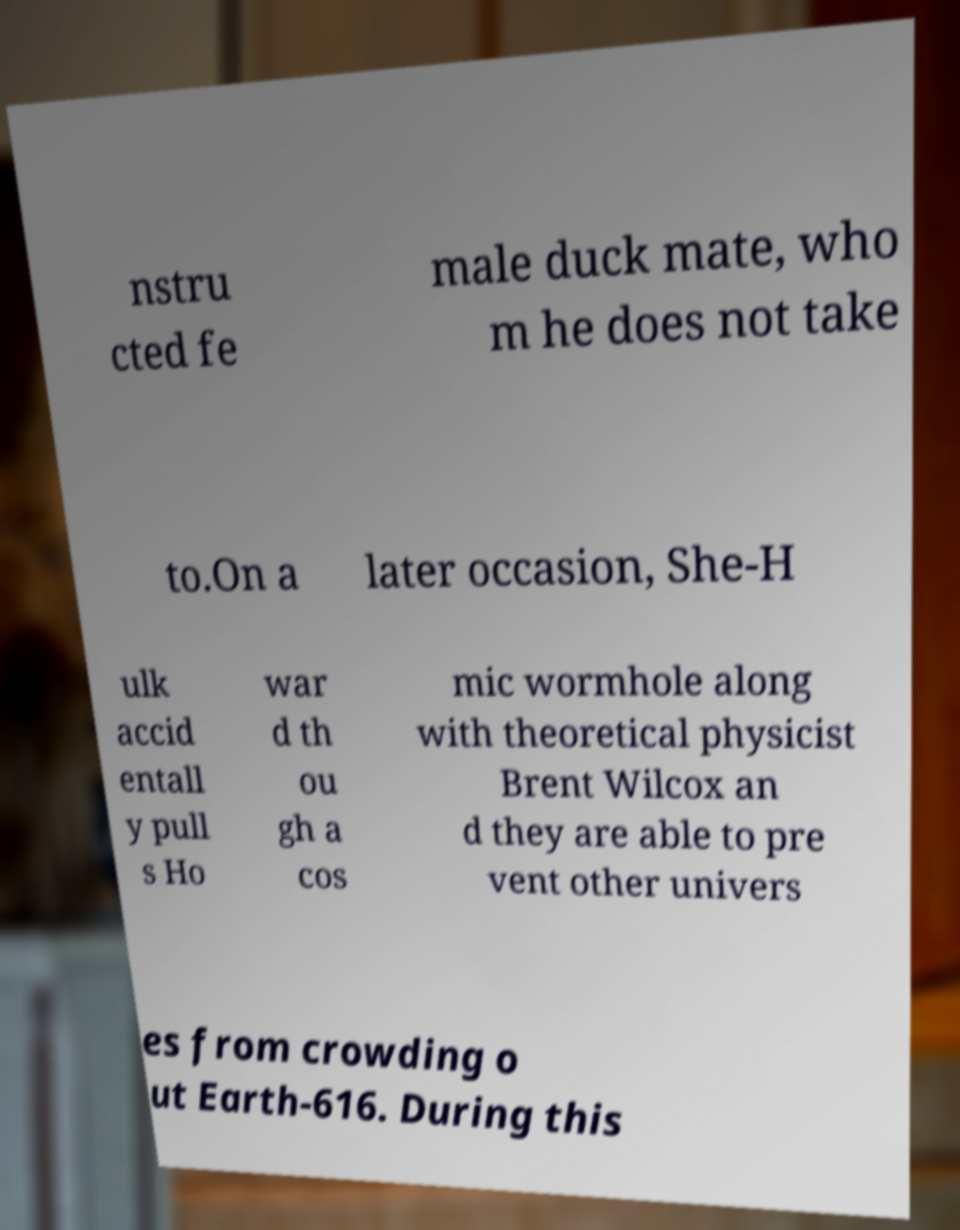Can you accurately transcribe the text from the provided image for me? nstru cted fe male duck mate, who m he does not take to.On a later occasion, She-H ulk accid entall y pull s Ho war d th ou gh a cos mic wormhole along with theoretical physicist Brent Wilcox an d they are able to pre vent other univers es from crowding o ut Earth-616. During this 